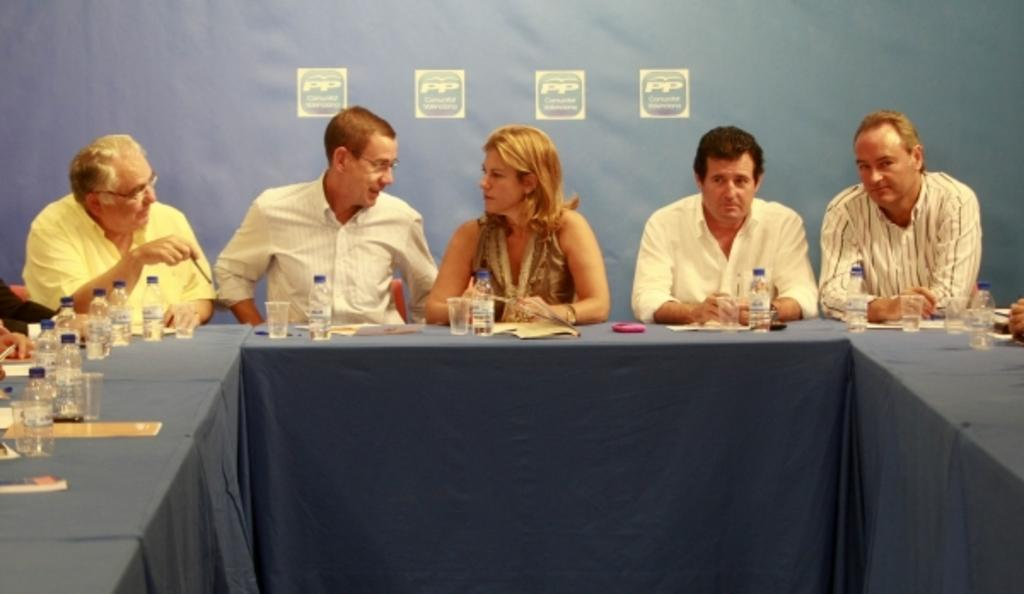How many people are present in the image? There are five people in the image. What are the people doing in the image? The people are sitting on chairs. Where are the chairs located in relation to the table? The chairs are near a table. What items can be seen on the table? There are many glasses and bottles on the table. What type of hill can be seen in the background of the image? There is no hill visible in the image; it features people sitting near a table with glasses and bottles. 